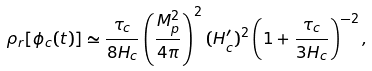<formula> <loc_0><loc_0><loc_500><loc_500>\rho _ { r } [ \phi _ { c } ( t ) ] \simeq \frac { \tau _ { c } } { 8 H _ { c } } \left ( \frac { M ^ { 2 } _ { p } } { 4 \pi } \right ) ^ { 2 } ( H ^ { \prime } _ { c } ) ^ { 2 } \left ( 1 + \frac { \tau _ { c } } { 3 H _ { c } } \right ) ^ { - 2 } ,</formula> 